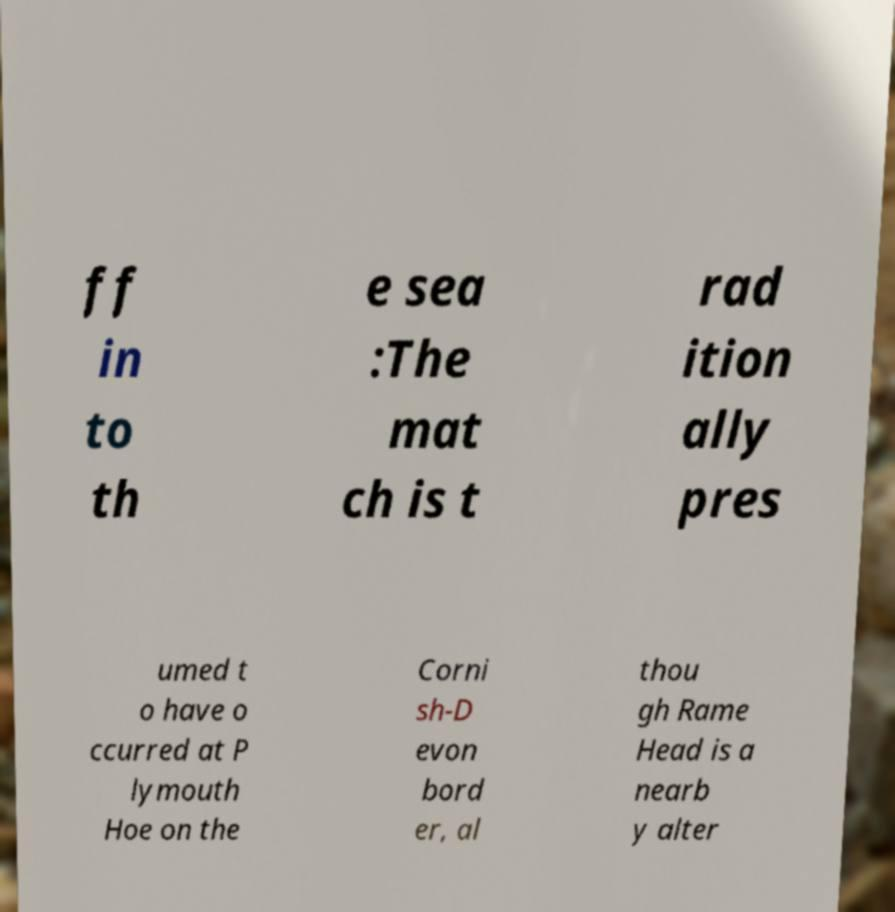Please read and relay the text visible in this image. What does it say? ff in to th e sea :The mat ch is t rad ition ally pres umed t o have o ccurred at P lymouth Hoe on the Corni sh-D evon bord er, al thou gh Rame Head is a nearb y alter 